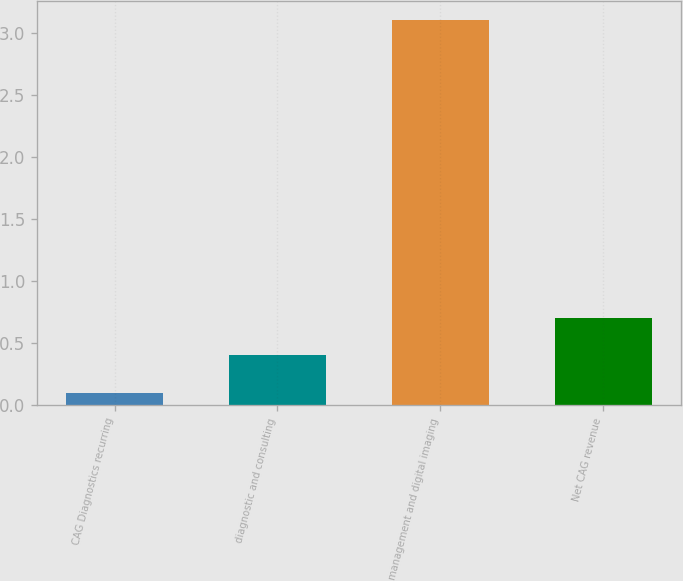<chart> <loc_0><loc_0><loc_500><loc_500><bar_chart><fcel>CAG Diagnostics recurring<fcel>diagnostic and consulting<fcel>management and digital imaging<fcel>Net CAG revenue<nl><fcel>0.1<fcel>0.4<fcel>3.1<fcel>0.7<nl></chart> 